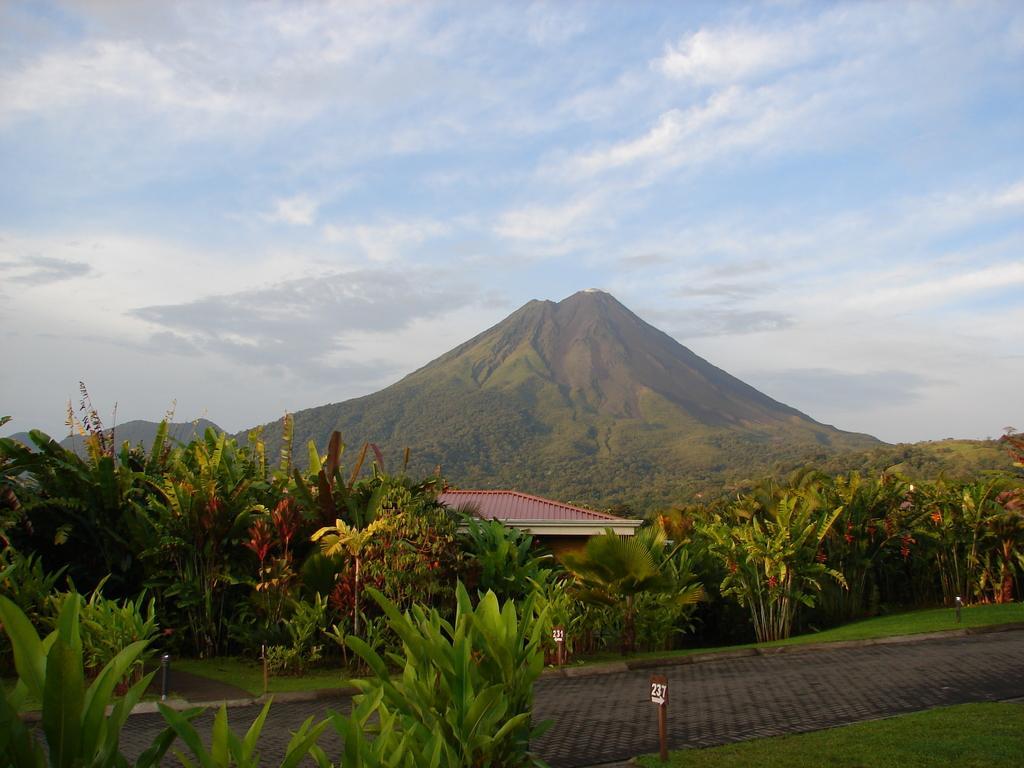Please provide a concise description of this image. In this image we can see some plants, poles, boards, trees, mountains and a house, in the background, we can see the sky with clouds. 